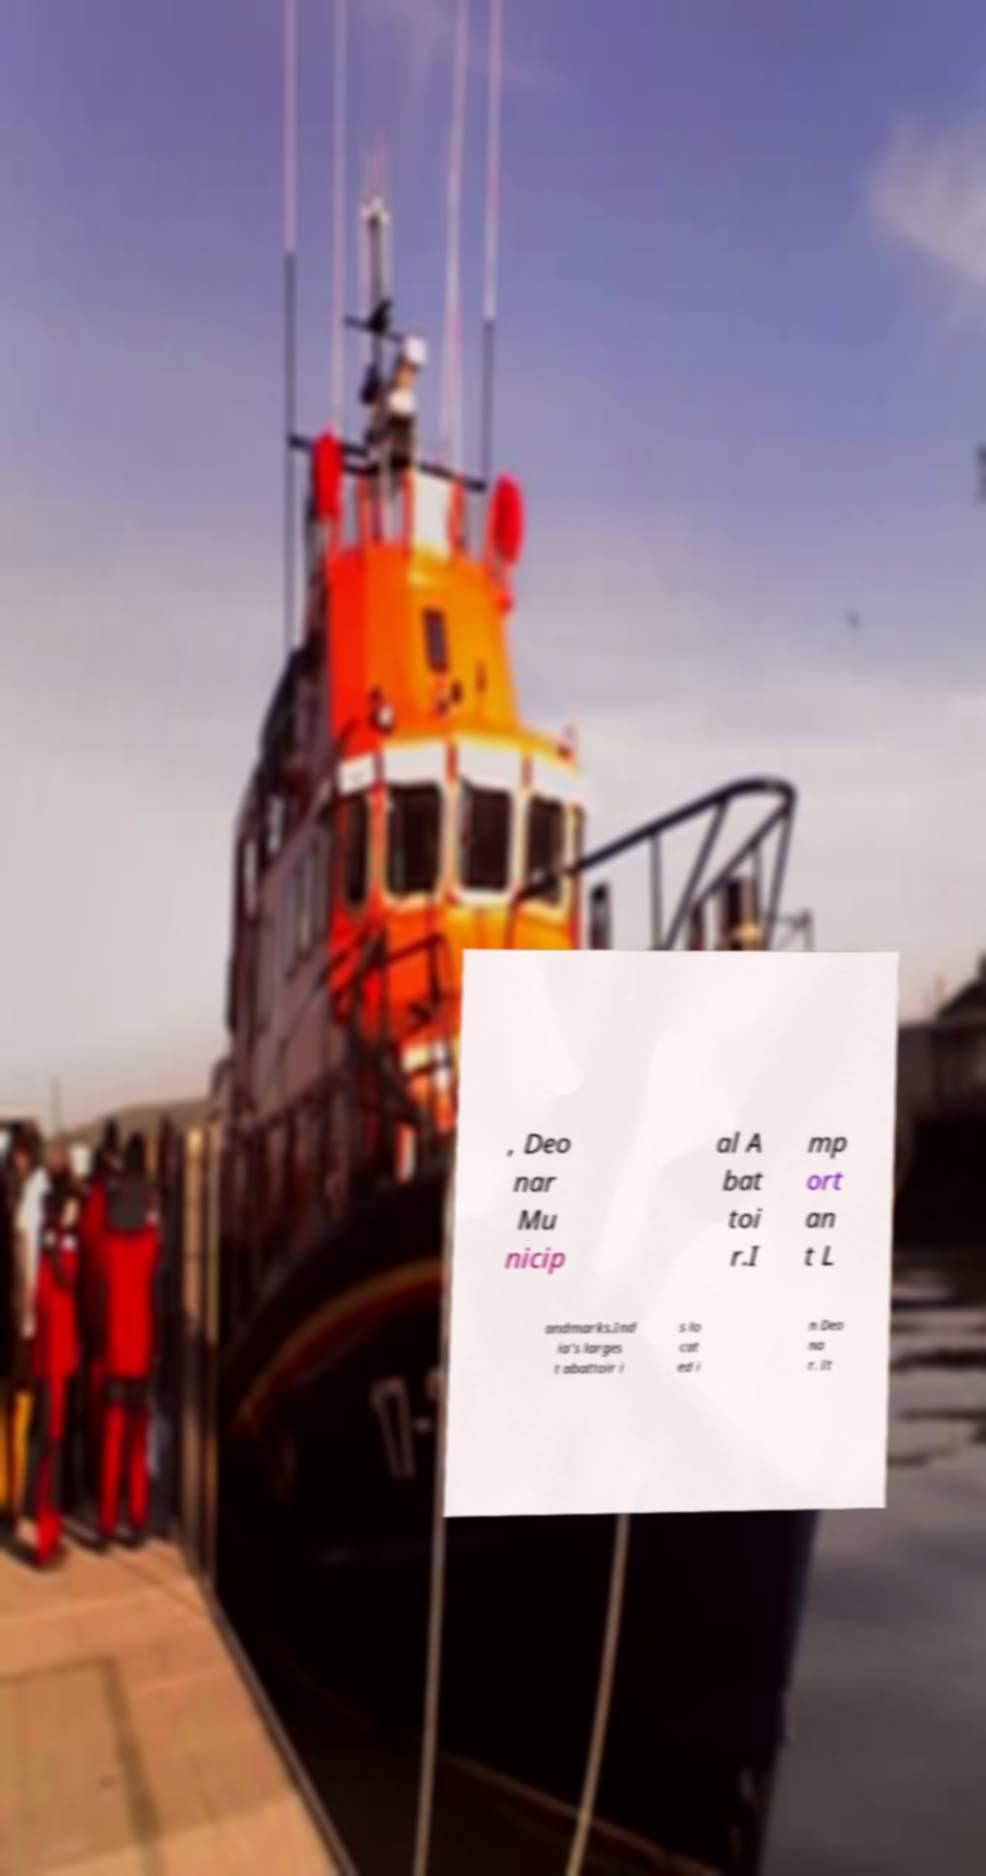There's text embedded in this image that I need extracted. Can you transcribe it verbatim? , Deo nar Mu nicip al A bat toi r.I mp ort an t L andmarks.Ind ia's larges t abattoir i s lo cat ed i n Deo na r. It 